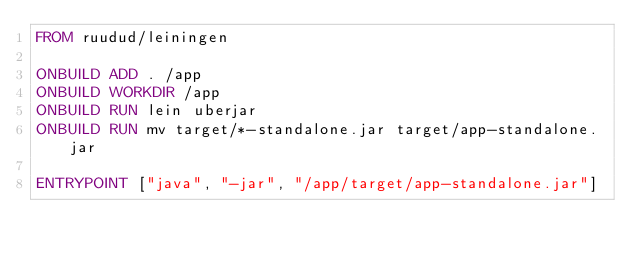Convert code to text. <code><loc_0><loc_0><loc_500><loc_500><_Dockerfile_>FROM ruudud/leiningen

ONBUILD ADD . /app
ONBUILD WORKDIR /app
ONBUILD RUN lein uberjar
ONBUILD RUN mv target/*-standalone.jar target/app-standalone.jar

ENTRYPOINT ["java", "-jar", "/app/target/app-standalone.jar"]
</code> 